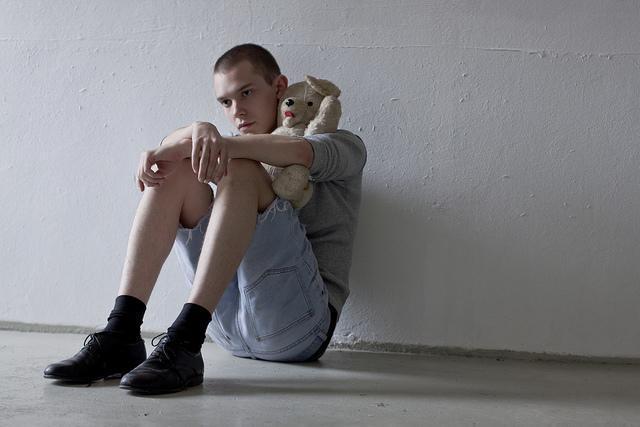Is "The person is beneath the teddy bear." an appropriate description for the image?
Answer yes or no. No. 